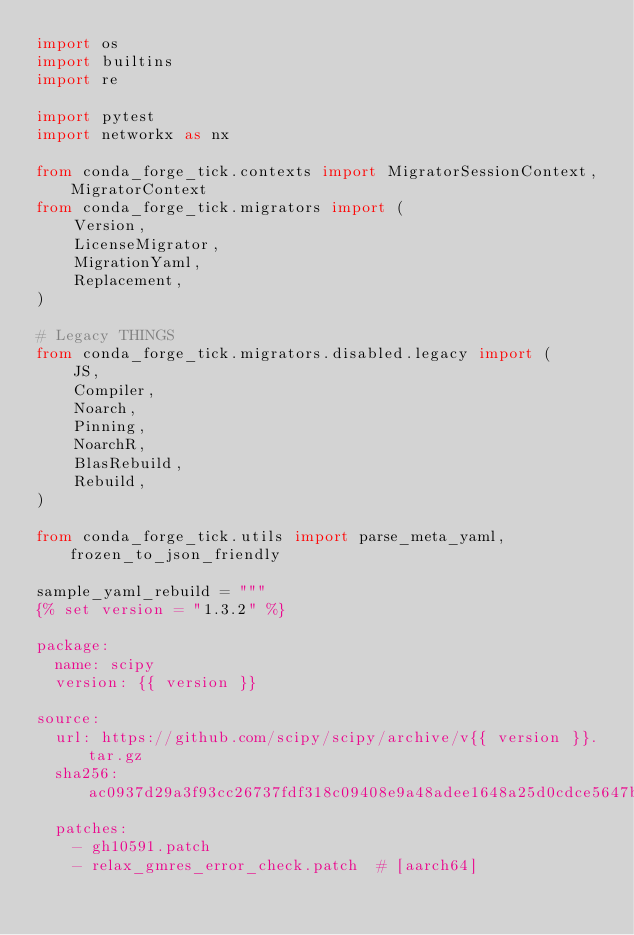<code> <loc_0><loc_0><loc_500><loc_500><_Python_>import os
import builtins
import re

import pytest
import networkx as nx

from conda_forge_tick.contexts import MigratorSessionContext, MigratorContext
from conda_forge_tick.migrators import (
    Version,
    LicenseMigrator,
    MigrationYaml,
    Replacement,
)

# Legacy THINGS
from conda_forge_tick.migrators.disabled.legacy import (
    JS,
    Compiler,
    Noarch,
    Pinning,
    NoarchR,
    BlasRebuild,
    Rebuild,
)

from conda_forge_tick.utils import parse_meta_yaml, frozen_to_json_friendly

sample_yaml_rebuild = """
{% set version = "1.3.2" %}

package:
  name: scipy
  version: {{ version }}

source:
  url: https://github.com/scipy/scipy/archive/v{{ version }}.tar.gz
  sha256: ac0937d29a3f93cc26737fdf318c09408e9a48adee1648a25d0cdce5647b8eb4
  patches:
    - gh10591.patch
    - relax_gmres_error_check.patch  # [aarch64]</code> 